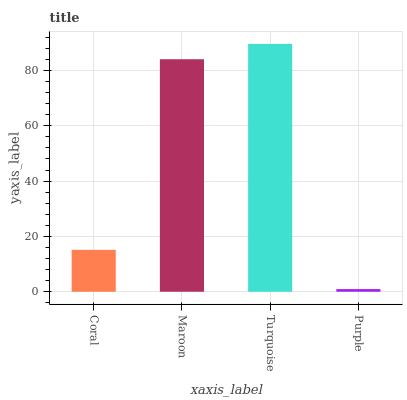Is Purple the minimum?
Answer yes or no. Yes. Is Turquoise the maximum?
Answer yes or no. Yes. Is Maroon the minimum?
Answer yes or no. No. Is Maroon the maximum?
Answer yes or no. No. Is Maroon greater than Coral?
Answer yes or no. Yes. Is Coral less than Maroon?
Answer yes or no. Yes. Is Coral greater than Maroon?
Answer yes or no. No. Is Maroon less than Coral?
Answer yes or no. No. Is Maroon the high median?
Answer yes or no. Yes. Is Coral the low median?
Answer yes or no. Yes. Is Turquoise the high median?
Answer yes or no. No. Is Turquoise the low median?
Answer yes or no. No. 